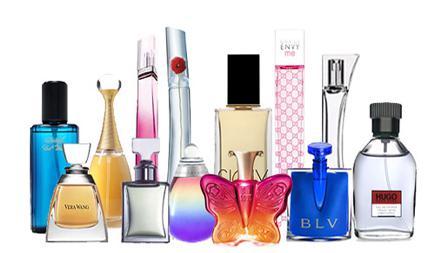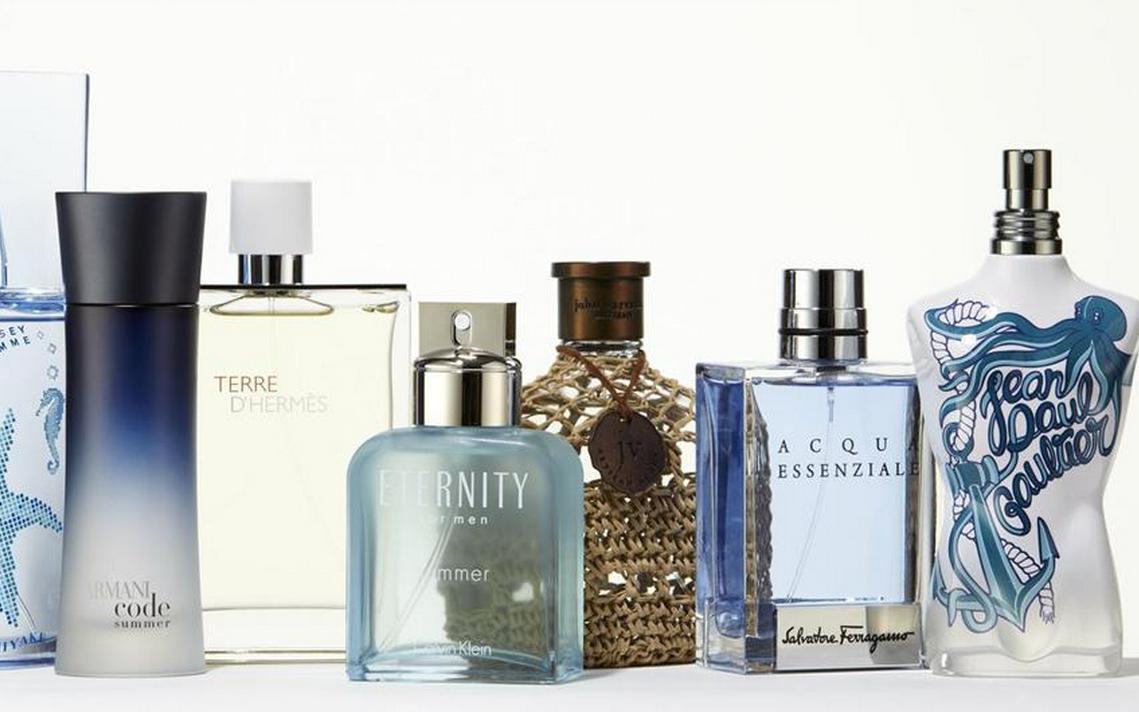The first image is the image on the left, the second image is the image on the right. Examine the images to the left and right. Is the description "In both images the products are all of varying heights." accurate? Answer yes or no. Yes. The first image is the image on the left, the second image is the image on the right. Analyze the images presented: Is the assertion "There are 9 or more label-less perfume bottles." valid? Answer yes or no. No. 